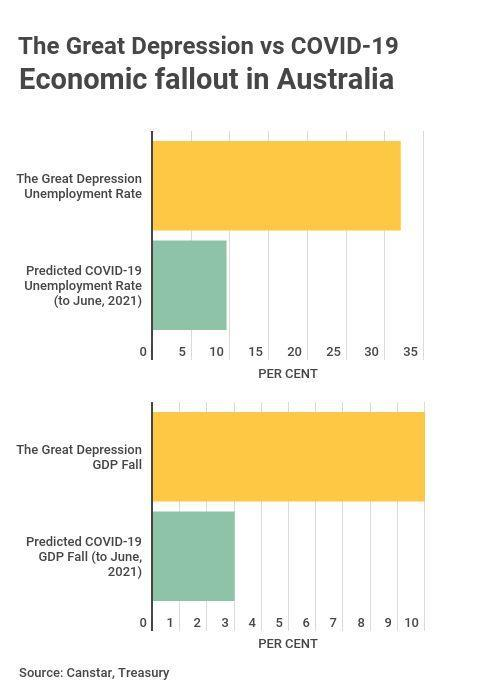Which colour represents the impact due to COVID, yellow or green
Answer the question with a short phrase. green What was the GDP Fall during the Great Depression 10 Which colour represents the impact due to the great depression, yellow or green yellow What is the GDP Fall predicted for COVID 3 